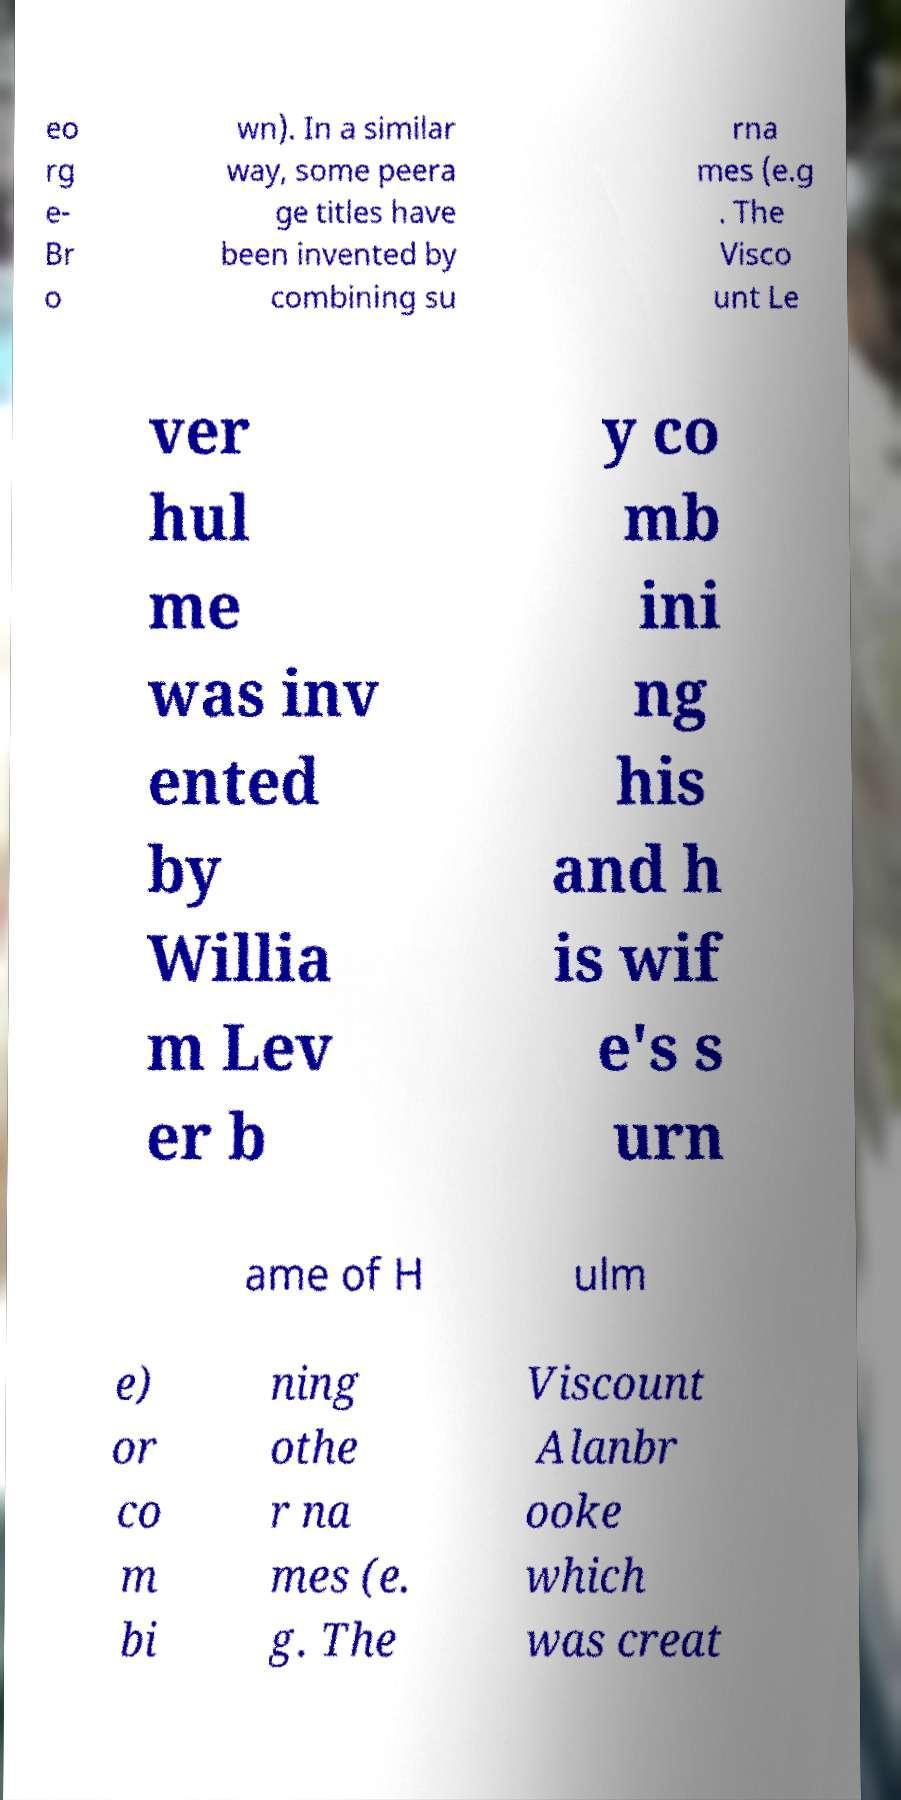What messages or text are displayed in this image? I need them in a readable, typed format. eo rg e- Br o wn). In a similar way, some peera ge titles have been invented by combining su rna mes (e.g . The Visco unt Le ver hul me was inv ented by Willia m Lev er b y co mb ini ng his and h is wif e's s urn ame of H ulm e) or co m bi ning othe r na mes (e. g. The Viscount Alanbr ooke which was creat 